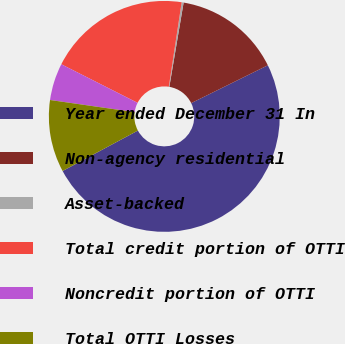<chart> <loc_0><loc_0><loc_500><loc_500><pie_chart><fcel>Year ended December 31 In<fcel>Non-agency residential<fcel>Asset-backed<fcel>Total credit portion of OTTI<fcel>Noncredit portion of OTTI<fcel>Total OTTI Losses<nl><fcel>49.46%<fcel>15.03%<fcel>0.27%<fcel>19.95%<fcel>5.19%<fcel>10.11%<nl></chart> 